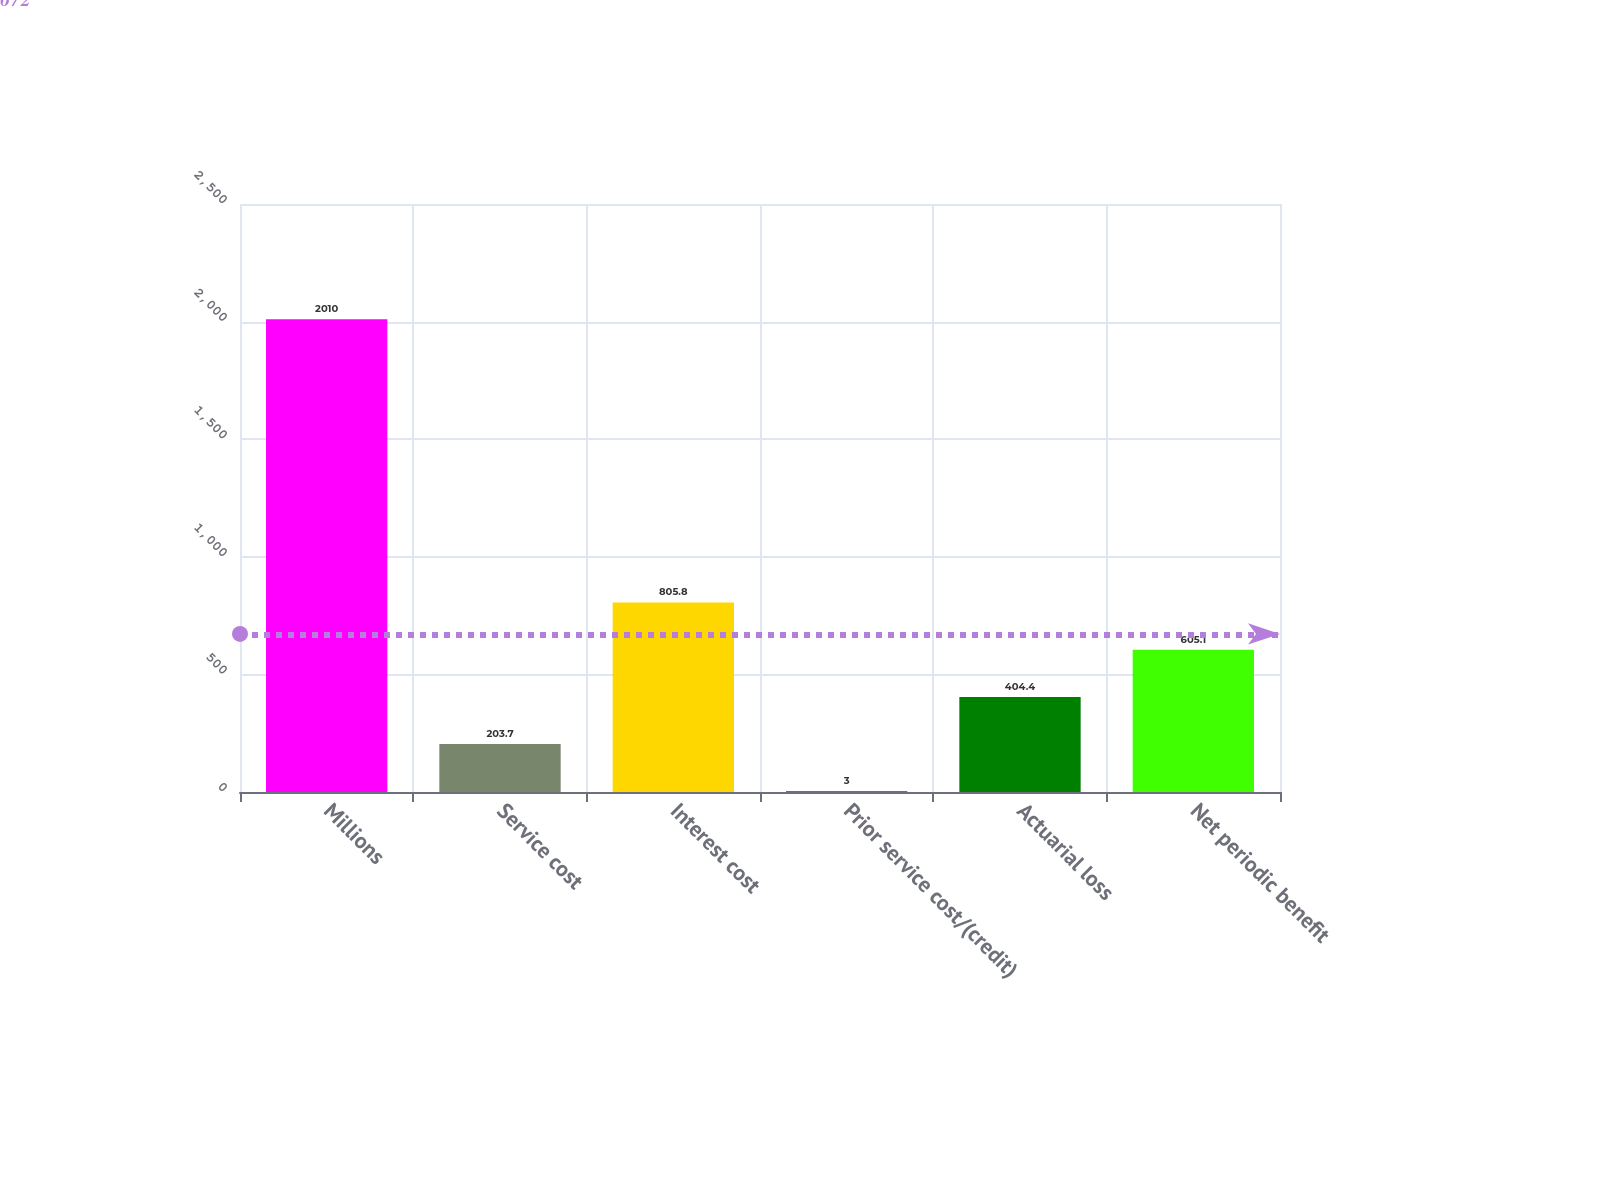<chart> <loc_0><loc_0><loc_500><loc_500><bar_chart><fcel>Millions<fcel>Service cost<fcel>Interest cost<fcel>Prior service cost/(credit)<fcel>Actuarial loss<fcel>Net periodic benefit<nl><fcel>2010<fcel>203.7<fcel>805.8<fcel>3<fcel>404.4<fcel>605.1<nl></chart> 